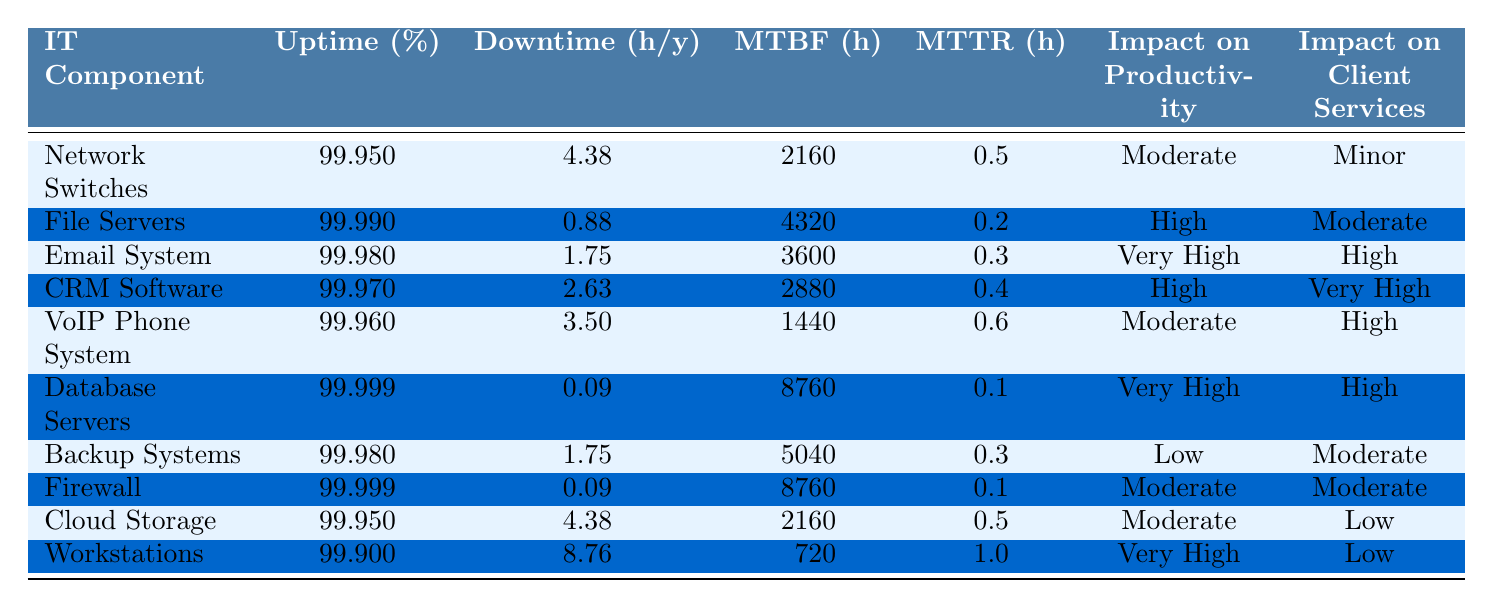What is the uptime percentage for the Email System? The Email System is listed in the table with an uptime percentage of 99.98%.
Answer: 99.98% Which IT component has the lowest downtime in hours per year? The Database Servers and Firewall both have the lowest downtime at 0.09 hours per year.
Answer: Database Servers and Firewall What is the MTTR for the CRM Software? The MTTR (Mean Time to Repair) for the CRM Software is 0.4 hours, as shown in the table.
Answer: 0.4 hours What is the difference in downtime between the File Servers and Workstations? The File Servers have 0.88 hours of downtime, while Workstations have 8.76 hours. The difference is 8.76 - 0.88 = 7.88 hours.
Answer: 7.88 hours Which IT components have a "Very High" impact on productivity? According to the table, the Email System, Database Servers, and Workstations are categorized with "Very High" impact on productivity.
Answer: Email System, Database Servers, Workstations What is the average uptime percentage of all IT components listed? To find the average uptime, sum all uptime percentages (99.95 + 99.99 + 99.98 + 99.97 + 99.96 + 99.999 + 99.98 + 99.999 + 99.95 + 99.90) = 999.89 and divide by 10 components. The average uptime percentage is 999.89 / 10 = 99.989%.
Answer: 99.989% Is the VoIP Phone System's MTTR greater than or equal to 0.5 hours? The MTTR for the VoIP Phone System is 0.6 hours, which is greater than 0.5 hours.
Answer: Yes Which IT component affects client services the most? The CRM Software has a "Very High" impact on client services, which is the highest category in the table.
Answer: CRM Software What is the total downtime for the Network Switches and Cloud Storage combined? The downtime for Network Switches is 4.38 hours, while Cloud Storage has 4.38 hours. Combined, they total 4.38 + 4.38 = 8.76 hours.
Answer: 8.76 hours Which IT component has the highest uptime percentage, and what is that percentage? The Database Servers and Firewall both have the highest uptime percentage of 99.999%.
Answer: 99.999% 